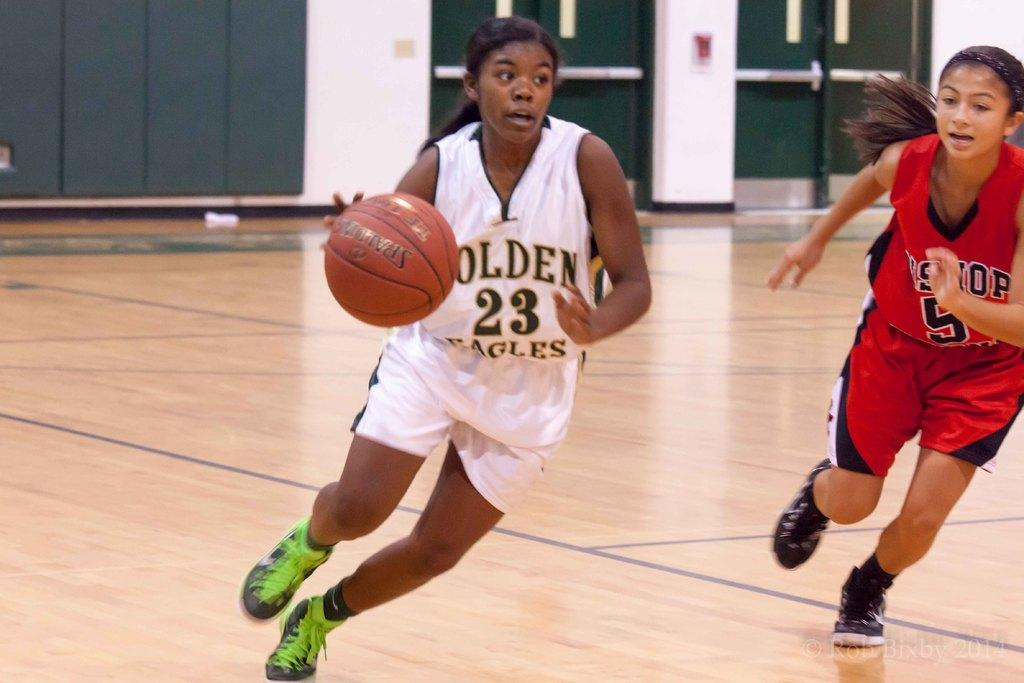Provide a one-sentence caption for the provided image. A female basketball player for the Eagles runs down the court with the ball. 